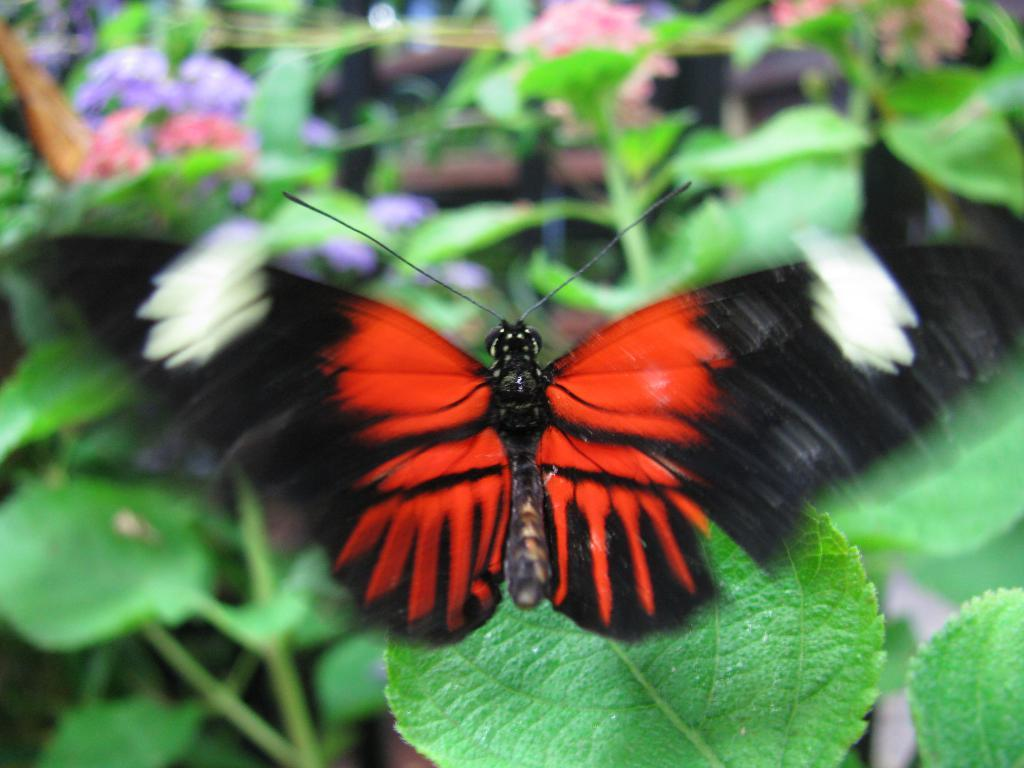What is the main subject of the image? The main subject of the image is a butterfly. Where is the butterfly located in the image? The butterfly is sitting on a leaf. What can be seen in the background of the image? There are many plants in the background of the image, but they are not clearly visible. What is the purpose of the coach in the image? There is no coach present in the image; it features a butterfly sitting on a leaf. Can you tell me how many monkeys are visible in the image? There are no monkeys visible in the image; it features a butterfly sitting on a leaf. 